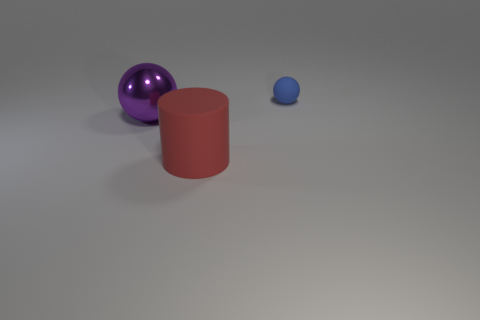Add 1 purple metal balls. How many objects exist? 4 Subtract all cylinders. How many objects are left? 2 Subtract 1 cylinders. How many cylinders are left? 0 Add 3 tiny green metal spheres. How many tiny green metal spheres exist? 3 Subtract 0 green cubes. How many objects are left? 3 Subtract all cyan cylinders. Subtract all red cubes. How many cylinders are left? 1 Subtract all purple cubes. How many brown spheres are left? 0 Subtract all tiny blue cylinders. Subtract all large purple shiny balls. How many objects are left? 2 Add 2 purple objects. How many purple objects are left? 3 